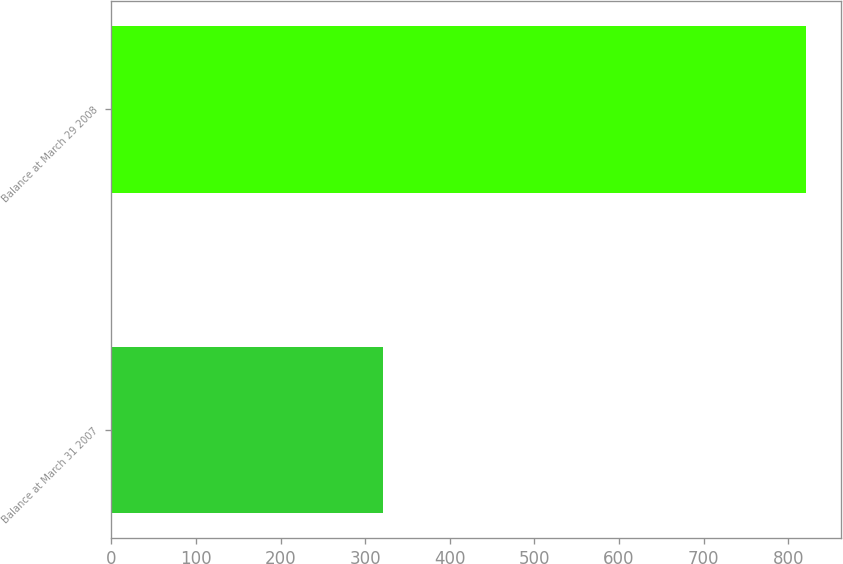Convert chart. <chart><loc_0><loc_0><loc_500><loc_500><bar_chart><fcel>Balance at March 31 2007<fcel>Balance at March 29 2008<nl><fcel>321.5<fcel>820.9<nl></chart> 